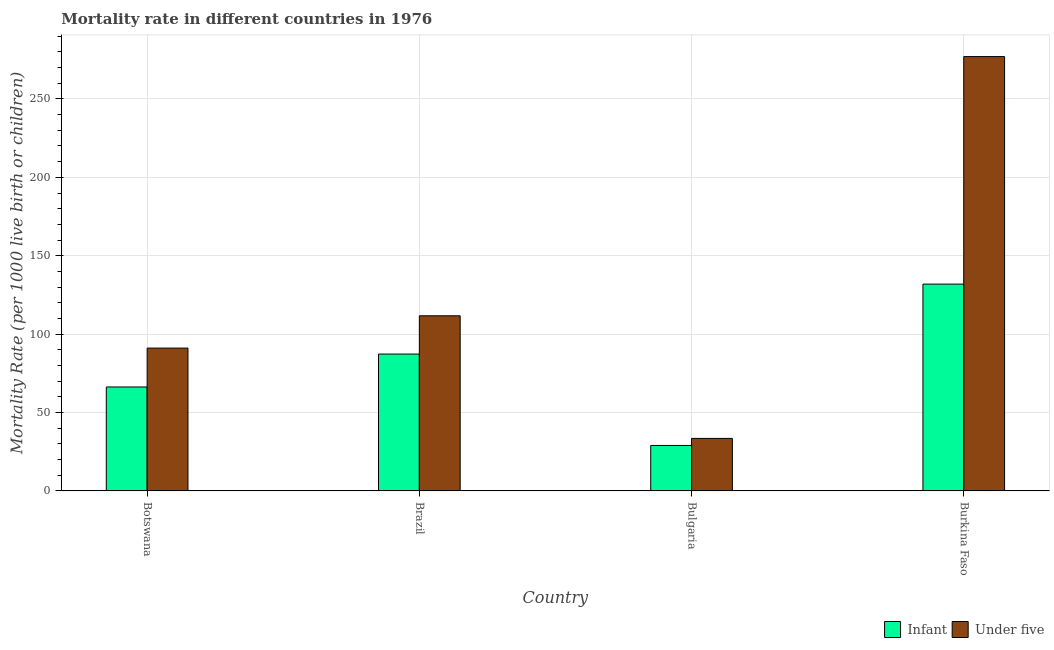How many different coloured bars are there?
Offer a terse response. 2. Are the number of bars on each tick of the X-axis equal?
Provide a short and direct response. Yes. What is the label of the 1st group of bars from the left?
Offer a very short reply. Botswana. In how many cases, is the number of bars for a given country not equal to the number of legend labels?
Your answer should be very brief. 0. What is the infant mortality rate in Brazil?
Your answer should be compact. 87.3. Across all countries, what is the maximum infant mortality rate?
Keep it short and to the point. 131.9. In which country was the infant mortality rate maximum?
Provide a succinct answer. Burkina Faso. What is the total infant mortality rate in the graph?
Your response must be concise. 314.5. What is the difference between the under-5 mortality rate in Brazil and that in Bulgaria?
Make the answer very short. 78.2. What is the difference between the under-5 mortality rate in Burkina Faso and the infant mortality rate in Botswana?
Your answer should be compact. 210.7. What is the average under-5 mortality rate per country?
Your response must be concise. 128.32. What is the difference between the under-5 mortality rate and infant mortality rate in Botswana?
Provide a succinct answer. 24.8. In how many countries, is the under-5 mortality rate greater than 120 ?
Your answer should be very brief. 1. What is the ratio of the infant mortality rate in Brazil to that in Burkina Faso?
Offer a very short reply. 0.66. Is the difference between the under-5 mortality rate in Bulgaria and Burkina Faso greater than the difference between the infant mortality rate in Bulgaria and Burkina Faso?
Your response must be concise. No. What is the difference between the highest and the second highest infant mortality rate?
Give a very brief answer. 44.6. What is the difference between the highest and the lowest under-5 mortality rate?
Provide a succinct answer. 243.5. In how many countries, is the infant mortality rate greater than the average infant mortality rate taken over all countries?
Your response must be concise. 2. What does the 2nd bar from the left in Brazil represents?
Ensure brevity in your answer.  Under five. What does the 1st bar from the right in Botswana represents?
Keep it short and to the point. Under five. How many countries are there in the graph?
Your answer should be very brief. 4. Are the values on the major ticks of Y-axis written in scientific E-notation?
Your answer should be compact. No. Where does the legend appear in the graph?
Your answer should be very brief. Bottom right. How are the legend labels stacked?
Offer a terse response. Horizontal. What is the title of the graph?
Make the answer very short. Mortality rate in different countries in 1976. Does "Fixed telephone" appear as one of the legend labels in the graph?
Provide a short and direct response. No. What is the label or title of the Y-axis?
Ensure brevity in your answer.  Mortality Rate (per 1000 live birth or children). What is the Mortality Rate (per 1000 live birth or children) in Infant in Botswana?
Keep it short and to the point. 66.3. What is the Mortality Rate (per 1000 live birth or children) in Under five in Botswana?
Provide a short and direct response. 91.1. What is the Mortality Rate (per 1000 live birth or children) of Infant in Brazil?
Your response must be concise. 87.3. What is the Mortality Rate (per 1000 live birth or children) of Under five in Brazil?
Make the answer very short. 111.7. What is the Mortality Rate (per 1000 live birth or children) of Under five in Bulgaria?
Your answer should be compact. 33.5. What is the Mortality Rate (per 1000 live birth or children) in Infant in Burkina Faso?
Make the answer very short. 131.9. What is the Mortality Rate (per 1000 live birth or children) of Under five in Burkina Faso?
Ensure brevity in your answer.  277. Across all countries, what is the maximum Mortality Rate (per 1000 live birth or children) of Infant?
Your answer should be compact. 131.9. Across all countries, what is the maximum Mortality Rate (per 1000 live birth or children) in Under five?
Offer a terse response. 277. Across all countries, what is the minimum Mortality Rate (per 1000 live birth or children) in Infant?
Give a very brief answer. 29. Across all countries, what is the minimum Mortality Rate (per 1000 live birth or children) in Under five?
Ensure brevity in your answer.  33.5. What is the total Mortality Rate (per 1000 live birth or children) of Infant in the graph?
Keep it short and to the point. 314.5. What is the total Mortality Rate (per 1000 live birth or children) in Under five in the graph?
Keep it short and to the point. 513.3. What is the difference between the Mortality Rate (per 1000 live birth or children) in Under five in Botswana and that in Brazil?
Ensure brevity in your answer.  -20.6. What is the difference between the Mortality Rate (per 1000 live birth or children) in Infant in Botswana and that in Bulgaria?
Provide a succinct answer. 37.3. What is the difference between the Mortality Rate (per 1000 live birth or children) of Under five in Botswana and that in Bulgaria?
Provide a succinct answer. 57.6. What is the difference between the Mortality Rate (per 1000 live birth or children) of Infant in Botswana and that in Burkina Faso?
Ensure brevity in your answer.  -65.6. What is the difference between the Mortality Rate (per 1000 live birth or children) in Under five in Botswana and that in Burkina Faso?
Your answer should be compact. -185.9. What is the difference between the Mortality Rate (per 1000 live birth or children) of Infant in Brazil and that in Bulgaria?
Keep it short and to the point. 58.3. What is the difference between the Mortality Rate (per 1000 live birth or children) in Under five in Brazil and that in Bulgaria?
Your response must be concise. 78.2. What is the difference between the Mortality Rate (per 1000 live birth or children) of Infant in Brazil and that in Burkina Faso?
Your answer should be compact. -44.6. What is the difference between the Mortality Rate (per 1000 live birth or children) in Under five in Brazil and that in Burkina Faso?
Offer a terse response. -165.3. What is the difference between the Mortality Rate (per 1000 live birth or children) in Infant in Bulgaria and that in Burkina Faso?
Provide a short and direct response. -102.9. What is the difference between the Mortality Rate (per 1000 live birth or children) in Under five in Bulgaria and that in Burkina Faso?
Provide a short and direct response. -243.5. What is the difference between the Mortality Rate (per 1000 live birth or children) of Infant in Botswana and the Mortality Rate (per 1000 live birth or children) of Under five in Brazil?
Provide a succinct answer. -45.4. What is the difference between the Mortality Rate (per 1000 live birth or children) of Infant in Botswana and the Mortality Rate (per 1000 live birth or children) of Under five in Bulgaria?
Provide a succinct answer. 32.8. What is the difference between the Mortality Rate (per 1000 live birth or children) of Infant in Botswana and the Mortality Rate (per 1000 live birth or children) of Under five in Burkina Faso?
Keep it short and to the point. -210.7. What is the difference between the Mortality Rate (per 1000 live birth or children) of Infant in Brazil and the Mortality Rate (per 1000 live birth or children) of Under five in Bulgaria?
Your response must be concise. 53.8. What is the difference between the Mortality Rate (per 1000 live birth or children) in Infant in Brazil and the Mortality Rate (per 1000 live birth or children) in Under five in Burkina Faso?
Provide a short and direct response. -189.7. What is the difference between the Mortality Rate (per 1000 live birth or children) in Infant in Bulgaria and the Mortality Rate (per 1000 live birth or children) in Under five in Burkina Faso?
Offer a very short reply. -248. What is the average Mortality Rate (per 1000 live birth or children) in Infant per country?
Give a very brief answer. 78.62. What is the average Mortality Rate (per 1000 live birth or children) of Under five per country?
Ensure brevity in your answer.  128.32. What is the difference between the Mortality Rate (per 1000 live birth or children) in Infant and Mortality Rate (per 1000 live birth or children) in Under five in Botswana?
Provide a short and direct response. -24.8. What is the difference between the Mortality Rate (per 1000 live birth or children) of Infant and Mortality Rate (per 1000 live birth or children) of Under five in Brazil?
Offer a terse response. -24.4. What is the difference between the Mortality Rate (per 1000 live birth or children) in Infant and Mortality Rate (per 1000 live birth or children) in Under five in Bulgaria?
Ensure brevity in your answer.  -4.5. What is the difference between the Mortality Rate (per 1000 live birth or children) in Infant and Mortality Rate (per 1000 live birth or children) in Under five in Burkina Faso?
Ensure brevity in your answer.  -145.1. What is the ratio of the Mortality Rate (per 1000 live birth or children) of Infant in Botswana to that in Brazil?
Your answer should be very brief. 0.76. What is the ratio of the Mortality Rate (per 1000 live birth or children) in Under five in Botswana to that in Brazil?
Offer a very short reply. 0.82. What is the ratio of the Mortality Rate (per 1000 live birth or children) in Infant in Botswana to that in Bulgaria?
Ensure brevity in your answer.  2.29. What is the ratio of the Mortality Rate (per 1000 live birth or children) of Under five in Botswana to that in Bulgaria?
Provide a short and direct response. 2.72. What is the ratio of the Mortality Rate (per 1000 live birth or children) of Infant in Botswana to that in Burkina Faso?
Keep it short and to the point. 0.5. What is the ratio of the Mortality Rate (per 1000 live birth or children) of Under five in Botswana to that in Burkina Faso?
Your answer should be very brief. 0.33. What is the ratio of the Mortality Rate (per 1000 live birth or children) in Infant in Brazil to that in Bulgaria?
Your response must be concise. 3.01. What is the ratio of the Mortality Rate (per 1000 live birth or children) of Under five in Brazil to that in Bulgaria?
Make the answer very short. 3.33. What is the ratio of the Mortality Rate (per 1000 live birth or children) in Infant in Brazil to that in Burkina Faso?
Provide a succinct answer. 0.66. What is the ratio of the Mortality Rate (per 1000 live birth or children) in Under five in Brazil to that in Burkina Faso?
Your response must be concise. 0.4. What is the ratio of the Mortality Rate (per 1000 live birth or children) in Infant in Bulgaria to that in Burkina Faso?
Provide a short and direct response. 0.22. What is the ratio of the Mortality Rate (per 1000 live birth or children) of Under five in Bulgaria to that in Burkina Faso?
Ensure brevity in your answer.  0.12. What is the difference between the highest and the second highest Mortality Rate (per 1000 live birth or children) in Infant?
Keep it short and to the point. 44.6. What is the difference between the highest and the second highest Mortality Rate (per 1000 live birth or children) of Under five?
Ensure brevity in your answer.  165.3. What is the difference between the highest and the lowest Mortality Rate (per 1000 live birth or children) of Infant?
Ensure brevity in your answer.  102.9. What is the difference between the highest and the lowest Mortality Rate (per 1000 live birth or children) in Under five?
Make the answer very short. 243.5. 